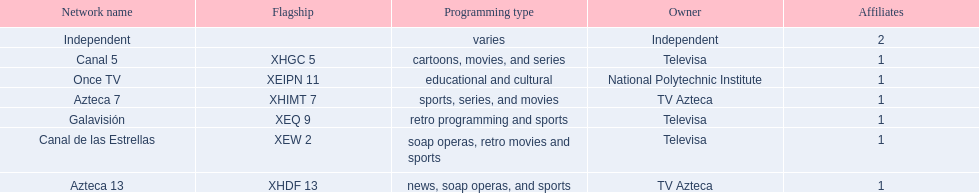Parse the full table. {'header': ['Network name', 'Flagship', 'Programming type', 'Owner', 'Affiliates'], 'rows': [['Independent', '', 'varies', 'Independent', '2'], ['Canal 5', 'XHGC 5', 'cartoons, movies, and series', 'Televisa', '1'], ['Once TV', 'XEIPN 11', 'educational and cultural', 'National Polytechnic Institute', '1'], ['Azteca 7', 'XHIMT 7', 'sports, series, and movies', 'TV Azteca', '1'], ['Galavisión', 'XEQ 9', 'retro programming and sports', 'Televisa', '1'], ['Canal de las Estrellas', 'XEW 2', 'soap operas, retro movies and sports', 'Televisa', '1'], ['Azteca 13', 'XHDF 13', 'news, soap operas, and sports', 'TV Azteca', '1']]} Who are the owners of the stations listed here? Televisa, Televisa, TV Azteca, Televisa, National Polytechnic Institute, TV Azteca, Independent. What is the one station owned by national polytechnic institute? Once TV. 